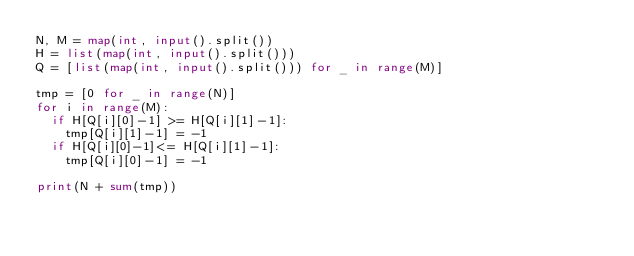<code> <loc_0><loc_0><loc_500><loc_500><_Python_>N, M = map(int, input().split())
H = list(map(int, input().split()))
Q = [list(map(int, input().split())) for _ in range(M)]

tmp = [0 for _ in range(N)]
for i in range(M):
  if H[Q[i][0]-1] >= H[Q[i][1]-1]:
    tmp[Q[i][1]-1] = -1
  if H[Q[i][0]-1]<= H[Q[i][1]-1]:
    tmp[Q[i][0]-1] = -1

print(N + sum(tmp))</code> 